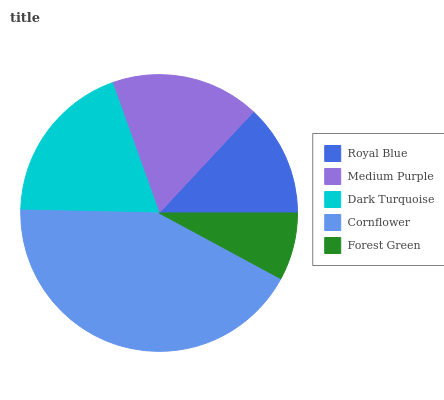Is Forest Green the minimum?
Answer yes or no. Yes. Is Cornflower the maximum?
Answer yes or no. Yes. Is Medium Purple the minimum?
Answer yes or no. No. Is Medium Purple the maximum?
Answer yes or no. No. Is Medium Purple greater than Royal Blue?
Answer yes or no. Yes. Is Royal Blue less than Medium Purple?
Answer yes or no. Yes. Is Royal Blue greater than Medium Purple?
Answer yes or no. No. Is Medium Purple less than Royal Blue?
Answer yes or no. No. Is Medium Purple the high median?
Answer yes or no. Yes. Is Medium Purple the low median?
Answer yes or no. Yes. Is Dark Turquoise the high median?
Answer yes or no. No. Is Forest Green the low median?
Answer yes or no. No. 